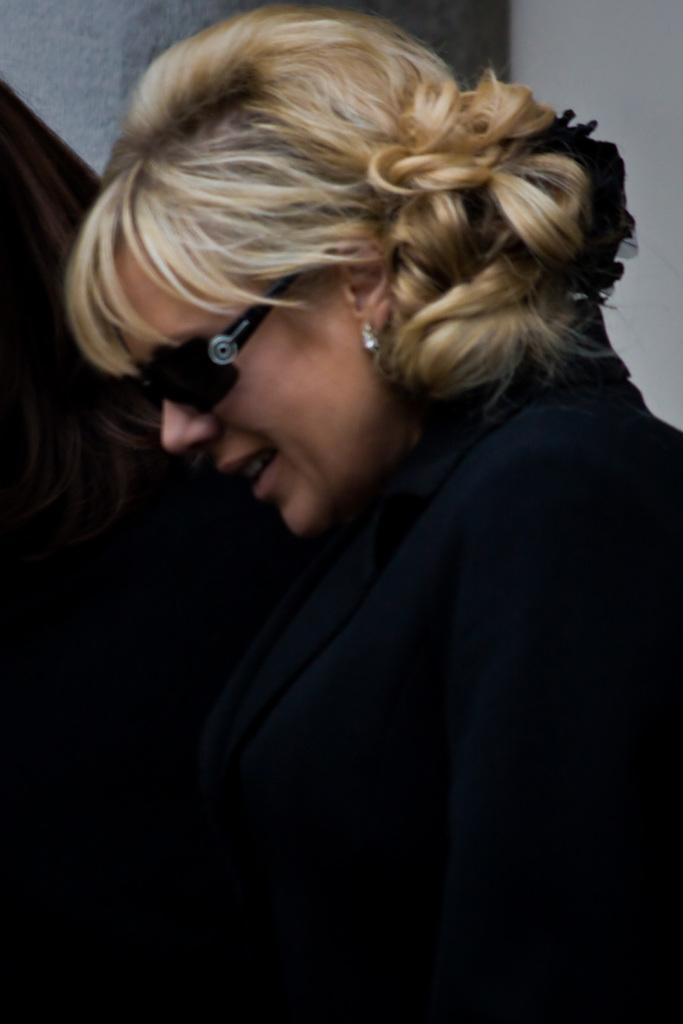Describe this image in one or two sentences. In this image we can see a woman and she has goggles to her eyes. In the background we can see wall and a person. 